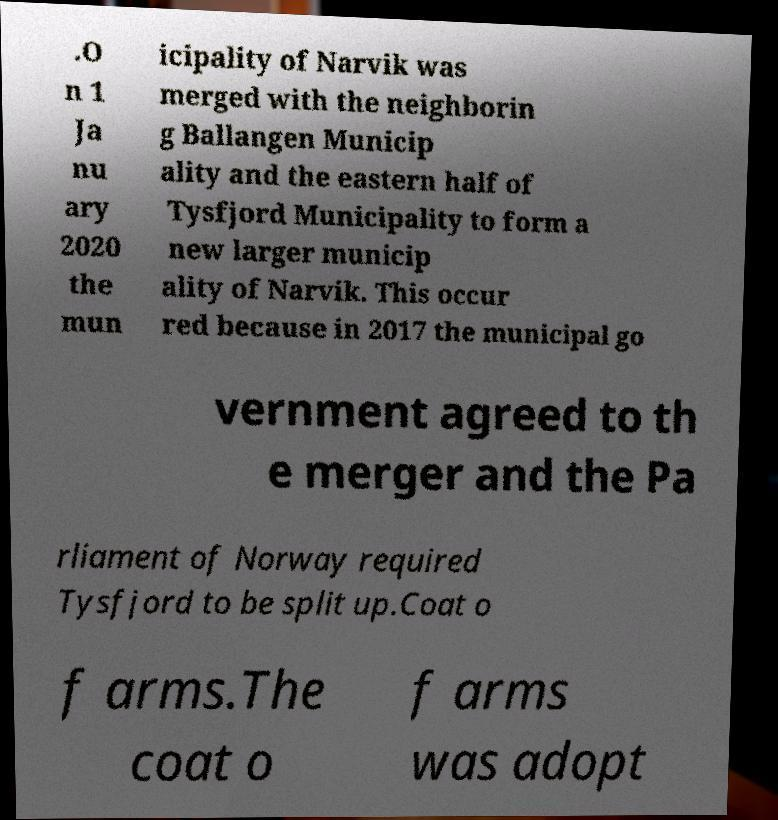Please identify and transcribe the text found in this image. .O n 1 Ja nu ary 2020 the mun icipality of Narvik was merged with the neighborin g Ballangen Municip ality and the eastern half of Tysfjord Municipality to form a new larger municip ality of Narvik. This occur red because in 2017 the municipal go vernment agreed to th e merger and the Pa rliament of Norway required Tysfjord to be split up.Coat o f arms.The coat o f arms was adopt 